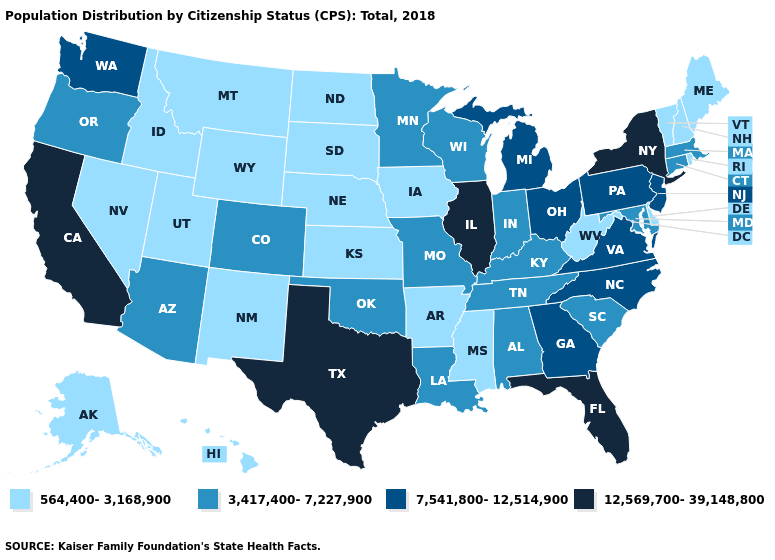Which states have the lowest value in the USA?
Write a very short answer. Alaska, Arkansas, Delaware, Hawaii, Idaho, Iowa, Kansas, Maine, Mississippi, Montana, Nebraska, Nevada, New Hampshire, New Mexico, North Dakota, Rhode Island, South Dakota, Utah, Vermont, West Virginia, Wyoming. What is the value of Louisiana?
Give a very brief answer. 3,417,400-7,227,900. Among the states that border New York , which have the highest value?
Write a very short answer. New Jersey, Pennsylvania. Does Rhode Island have the lowest value in the Northeast?
Give a very brief answer. Yes. What is the value of Missouri?
Write a very short answer. 3,417,400-7,227,900. Which states hav the highest value in the West?
Quick response, please. California. Name the states that have a value in the range 564,400-3,168,900?
Concise answer only. Alaska, Arkansas, Delaware, Hawaii, Idaho, Iowa, Kansas, Maine, Mississippi, Montana, Nebraska, Nevada, New Hampshire, New Mexico, North Dakota, Rhode Island, South Dakota, Utah, Vermont, West Virginia, Wyoming. Does Kentucky have a higher value than Iowa?
Be succinct. Yes. Name the states that have a value in the range 7,541,800-12,514,900?
Be succinct. Georgia, Michigan, New Jersey, North Carolina, Ohio, Pennsylvania, Virginia, Washington. Which states have the highest value in the USA?
Keep it brief. California, Florida, Illinois, New York, Texas. What is the value of Colorado?
Keep it brief. 3,417,400-7,227,900. Does Texas have the lowest value in the USA?
Write a very short answer. No. What is the lowest value in states that border Missouri?
Concise answer only. 564,400-3,168,900. What is the value of Vermont?
Keep it brief. 564,400-3,168,900. Is the legend a continuous bar?
Quick response, please. No. 